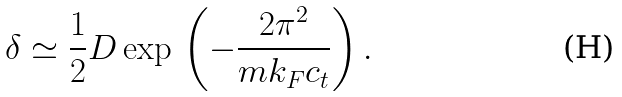<formula> <loc_0><loc_0><loc_500><loc_500>\delta \simeq \frac { 1 } { 2 } D \exp \, \left ( - \frac { 2 \pi ^ { 2 } } { m k _ { F } c _ { t } } \right ) .</formula> 